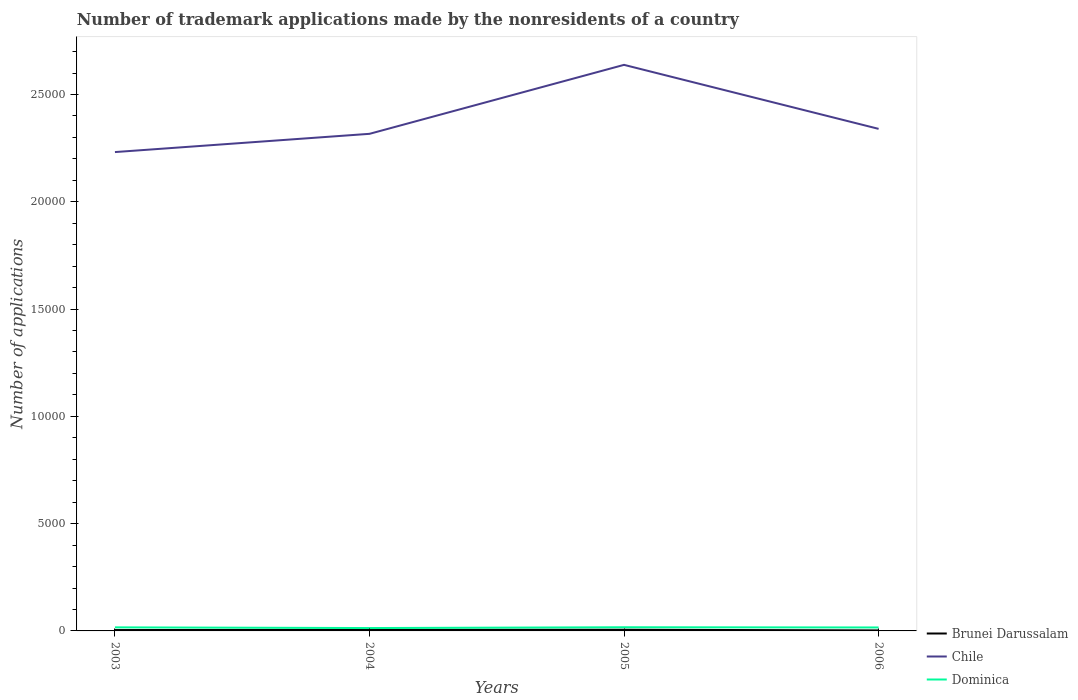How many different coloured lines are there?
Give a very brief answer. 3. Does the line corresponding to Brunei Darussalam intersect with the line corresponding to Dominica?
Offer a terse response. No. Is the number of lines equal to the number of legend labels?
Your answer should be compact. Yes. Across all years, what is the maximum number of trademark applications made by the nonresidents in Dominica?
Give a very brief answer. 134. What is the total number of trademark applications made by the nonresidents in Dominica in the graph?
Keep it short and to the point. -37. What is the difference between the highest and the lowest number of trademark applications made by the nonresidents in Chile?
Your answer should be compact. 1. Is the number of trademark applications made by the nonresidents in Dominica strictly greater than the number of trademark applications made by the nonresidents in Chile over the years?
Your answer should be compact. Yes. How many lines are there?
Keep it short and to the point. 3. What is the difference between two consecutive major ticks on the Y-axis?
Your answer should be very brief. 5000. Does the graph contain any zero values?
Offer a very short reply. No. How are the legend labels stacked?
Provide a succinct answer. Vertical. What is the title of the graph?
Offer a very short reply. Number of trademark applications made by the nonresidents of a country. Does "Congo (Republic)" appear as one of the legend labels in the graph?
Your answer should be compact. No. What is the label or title of the Y-axis?
Provide a succinct answer. Number of applications. What is the Number of applications in Chile in 2003?
Ensure brevity in your answer.  2.23e+04. What is the Number of applications in Dominica in 2003?
Keep it short and to the point. 166. What is the Number of applications in Chile in 2004?
Make the answer very short. 2.32e+04. What is the Number of applications in Dominica in 2004?
Ensure brevity in your answer.  134. What is the Number of applications in Chile in 2005?
Offer a terse response. 2.64e+04. What is the Number of applications of Dominica in 2005?
Keep it short and to the point. 171. What is the Number of applications of Chile in 2006?
Your answer should be very brief. 2.34e+04. What is the Number of applications of Dominica in 2006?
Keep it short and to the point. 161. Across all years, what is the maximum Number of applications in Brunei Darussalam?
Your response must be concise. 56. Across all years, what is the maximum Number of applications in Chile?
Make the answer very short. 2.64e+04. Across all years, what is the maximum Number of applications in Dominica?
Your answer should be compact. 171. Across all years, what is the minimum Number of applications of Brunei Darussalam?
Offer a terse response. 24. Across all years, what is the minimum Number of applications in Chile?
Your answer should be very brief. 2.23e+04. Across all years, what is the minimum Number of applications of Dominica?
Offer a very short reply. 134. What is the total Number of applications in Brunei Darussalam in the graph?
Ensure brevity in your answer.  172. What is the total Number of applications of Chile in the graph?
Ensure brevity in your answer.  9.53e+04. What is the total Number of applications of Dominica in the graph?
Provide a short and direct response. 632. What is the difference between the Number of applications of Brunei Darussalam in 2003 and that in 2004?
Provide a short and direct response. -10. What is the difference between the Number of applications of Chile in 2003 and that in 2004?
Provide a succinct answer. -850. What is the difference between the Number of applications of Brunei Darussalam in 2003 and that in 2005?
Your response must be concise. -15. What is the difference between the Number of applications of Chile in 2003 and that in 2005?
Provide a succinct answer. -4065. What is the difference between the Number of applications in Dominica in 2003 and that in 2005?
Your answer should be very brief. -5. What is the difference between the Number of applications in Chile in 2003 and that in 2006?
Offer a terse response. -1082. What is the difference between the Number of applications in Brunei Darussalam in 2004 and that in 2005?
Keep it short and to the point. -5. What is the difference between the Number of applications of Chile in 2004 and that in 2005?
Ensure brevity in your answer.  -3215. What is the difference between the Number of applications of Dominica in 2004 and that in 2005?
Provide a succinct answer. -37. What is the difference between the Number of applications in Chile in 2004 and that in 2006?
Your response must be concise. -232. What is the difference between the Number of applications in Brunei Darussalam in 2005 and that in 2006?
Your answer should be compact. 32. What is the difference between the Number of applications in Chile in 2005 and that in 2006?
Keep it short and to the point. 2983. What is the difference between the Number of applications of Brunei Darussalam in 2003 and the Number of applications of Chile in 2004?
Give a very brief answer. -2.31e+04. What is the difference between the Number of applications of Brunei Darussalam in 2003 and the Number of applications of Dominica in 2004?
Your answer should be compact. -93. What is the difference between the Number of applications in Chile in 2003 and the Number of applications in Dominica in 2004?
Keep it short and to the point. 2.22e+04. What is the difference between the Number of applications of Brunei Darussalam in 2003 and the Number of applications of Chile in 2005?
Your answer should be compact. -2.63e+04. What is the difference between the Number of applications of Brunei Darussalam in 2003 and the Number of applications of Dominica in 2005?
Your response must be concise. -130. What is the difference between the Number of applications in Chile in 2003 and the Number of applications in Dominica in 2005?
Provide a short and direct response. 2.21e+04. What is the difference between the Number of applications in Brunei Darussalam in 2003 and the Number of applications in Chile in 2006?
Offer a terse response. -2.34e+04. What is the difference between the Number of applications in Brunei Darussalam in 2003 and the Number of applications in Dominica in 2006?
Keep it short and to the point. -120. What is the difference between the Number of applications of Chile in 2003 and the Number of applications of Dominica in 2006?
Keep it short and to the point. 2.22e+04. What is the difference between the Number of applications in Brunei Darussalam in 2004 and the Number of applications in Chile in 2005?
Provide a succinct answer. -2.63e+04. What is the difference between the Number of applications of Brunei Darussalam in 2004 and the Number of applications of Dominica in 2005?
Provide a short and direct response. -120. What is the difference between the Number of applications of Chile in 2004 and the Number of applications of Dominica in 2005?
Give a very brief answer. 2.30e+04. What is the difference between the Number of applications in Brunei Darussalam in 2004 and the Number of applications in Chile in 2006?
Ensure brevity in your answer.  -2.33e+04. What is the difference between the Number of applications in Brunei Darussalam in 2004 and the Number of applications in Dominica in 2006?
Provide a succinct answer. -110. What is the difference between the Number of applications in Chile in 2004 and the Number of applications in Dominica in 2006?
Give a very brief answer. 2.30e+04. What is the difference between the Number of applications of Brunei Darussalam in 2005 and the Number of applications of Chile in 2006?
Give a very brief answer. -2.33e+04. What is the difference between the Number of applications in Brunei Darussalam in 2005 and the Number of applications in Dominica in 2006?
Your answer should be very brief. -105. What is the difference between the Number of applications in Chile in 2005 and the Number of applications in Dominica in 2006?
Provide a short and direct response. 2.62e+04. What is the average Number of applications in Brunei Darussalam per year?
Give a very brief answer. 43. What is the average Number of applications in Chile per year?
Provide a succinct answer. 2.38e+04. What is the average Number of applications of Dominica per year?
Make the answer very short. 158. In the year 2003, what is the difference between the Number of applications in Brunei Darussalam and Number of applications in Chile?
Provide a short and direct response. -2.23e+04. In the year 2003, what is the difference between the Number of applications in Brunei Darussalam and Number of applications in Dominica?
Your answer should be compact. -125. In the year 2003, what is the difference between the Number of applications in Chile and Number of applications in Dominica?
Your response must be concise. 2.22e+04. In the year 2004, what is the difference between the Number of applications of Brunei Darussalam and Number of applications of Chile?
Your answer should be compact. -2.31e+04. In the year 2004, what is the difference between the Number of applications of Brunei Darussalam and Number of applications of Dominica?
Make the answer very short. -83. In the year 2004, what is the difference between the Number of applications of Chile and Number of applications of Dominica?
Give a very brief answer. 2.30e+04. In the year 2005, what is the difference between the Number of applications in Brunei Darussalam and Number of applications in Chile?
Keep it short and to the point. -2.63e+04. In the year 2005, what is the difference between the Number of applications of Brunei Darussalam and Number of applications of Dominica?
Your answer should be very brief. -115. In the year 2005, what is the difference between the Number of applications in Chile and Number of applications in Dominica?
Your answer should be very brief. 2.62e+04. In the year 2006, what is the difference between the Number of applications of Brunei Darussalam and Number of applications of Chile?
Keep it short and to the point. -2.34e+04. In the year 2006, what is the difference between the Number of applications of Brunei Darussalam and Number of applications of Dominica?
Keep it short and to the point. -137. In the year 2006, what is the difference between the Number of applications in Chile and Number of applications in Dominica?
Provide a short and direct response. 2.32e+04. What is the ratio of the Number of applications in Brunei Darussalam in 2003 to that in 2004?
Keep it short and to the point. 0.8. What is the ratio of the Number of applications of Chile in 2003 to that in 2004?
Offer a terse response. 0.96. What is the ratio of the Number of applications in Dominica in 2003 to that in 2004?
Provide a short and direct response. 1.24. What is the ratio of the Number of applications in Brunei Darussalam in 2003 to that in 2005?
Keep it short and to the point. 0.73. What is the ratio of the Number of applications in Chile in 2003 to that in 2005?
Your response must be concise. 0.85. What is the ratio of the Number of applications of Dominica in 2003 to that in 2005?
Offer a terse response. 0.97. What is the ratio of the Number of applications of Brunei Darussalam in 2003 to that in 2006?
Ensure brevity in your answer.  1.71. What is the ratio of the Number of applications of Chile in 2003 to that in 2006?
Your answer should be very brief. 0.95. What is the ratio of the Number of applications in Dominica in 2003 to that in 2006?
Make the answer very short. 1.03. What is the ratio of the Number of applications in Brunei Darussalam in 2004 to that in 2005?
Make the answer very short. 0.91. What is the ratio of the Number of applications of Chile in 2004 to that in 2005?
Provide a short and direct response. 0.88. What is the ratio of the Number of applications in Dominica in 2004 to that in 2005?
Your response must be concise. 0.78. What is the ratio of the Number of applications in Brunei Darussalam in 2004 to that in 2006?
Offer a very short reply. 2.12. What is the ratio of the Number of applications of Dominica in 2004 to that in 2006?
Your response must be concise. 0.83. What is the ratio of the Number of applications of Brunei Darussalam in 2005 to that in 2006?
Make the answer very short. 2.33. What is the ratio of the Number of applications of Chile in 2005 to that in 2006?
Offer a very short reply. 1.13. What is the ratio of the Number of applications of Dominica in 2005 to that in 2006?
Your response must be concise. 1.06. What is the difference between the highest and the second highest Number of applications of Chile?
Your answer should be compact. 2983. What is the difference between the highest and the lowest Number of applications of Chile?
Provide a short and direct response. 4065. What is the difference between the highest and the lowest Number of applications in Dominica?
Your answer should be very brief. 37. 